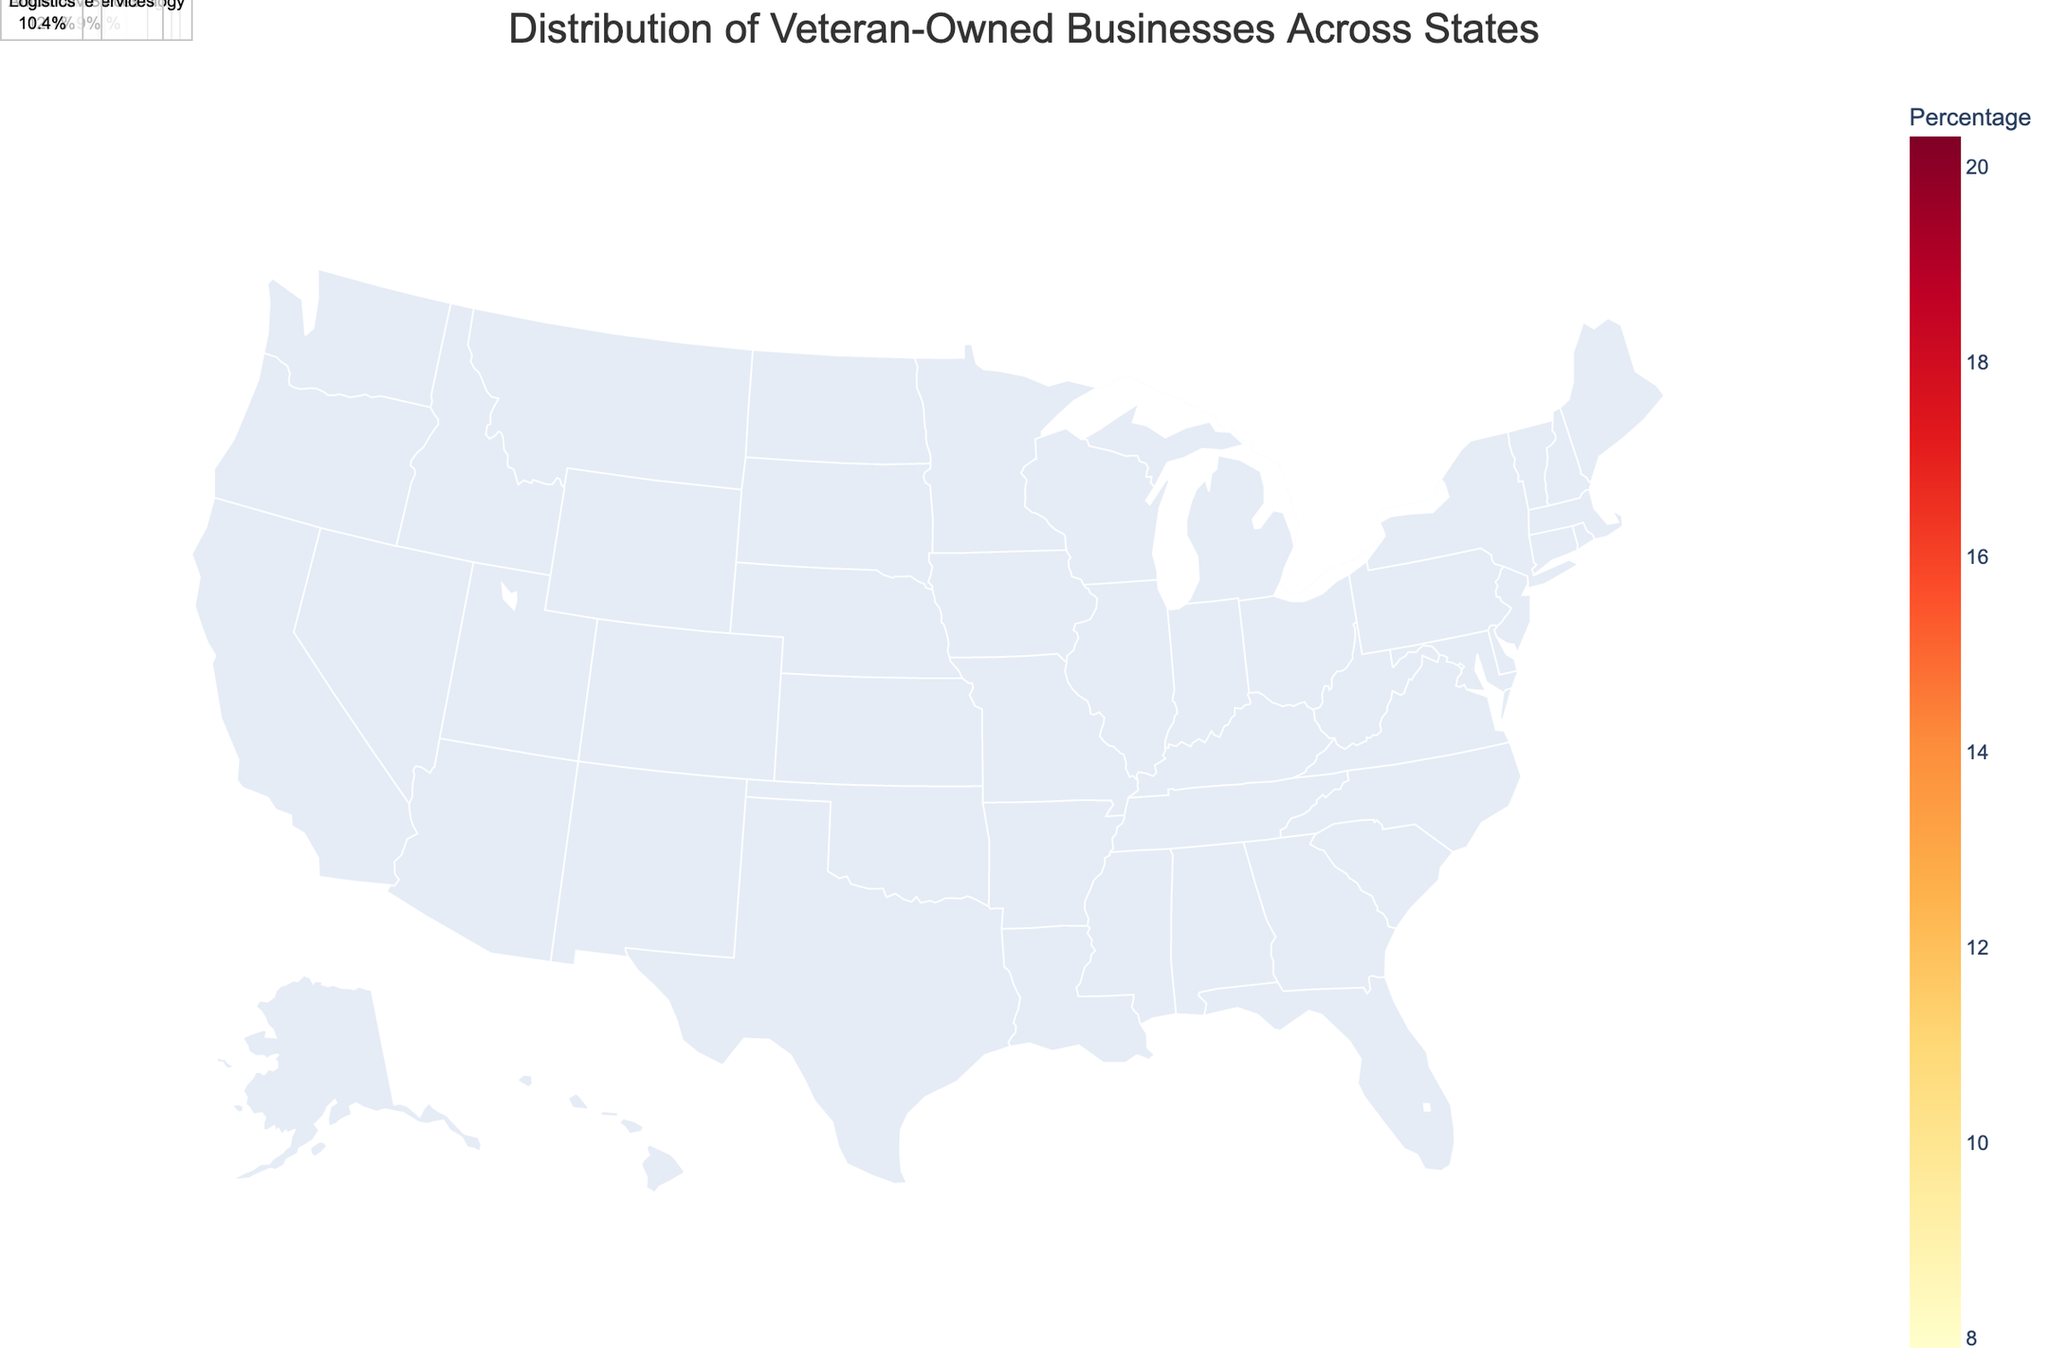What's the title of the figure? The title is displayed at the top of the figure, indicating the main topic it covers. It helps the viewer to understand the overall content at a glance.
Answer: Distribution of Veteran-Owned Businesses Across States Which state has the highest percentage of veteran-owned businesses in defense contracting? By looking at the color coding and hover information, you locate the state labeled with the highest percentage in the defense contracting industry.
Answer: Virginia What industry has a 17.5% share of veteran-owned businesses in Arizona? The chart annotates the state along with associated industry and percentage figures. Locate Arizona and read off the corresponding industry.
Answer: Security Services Compare the percentage of veteran-owned businesses involved in manufacturing in Ohio and the percentage in aerospace in Colorado. Which is higher? Locate Ohio and Colorado on the map, check their associated percentages for manufacturing and aerospace respectively, and compare the two figures.
Answer: Aerospace in Colorado What's the average percentage of veteran-owned businesses in healthcare, logistics, and agriculture in North Carolina, Alabama, and Illinois respectively? Calculate the average of the percentages: (10.6 (Healthcare in NC) + 10.4 (Logistics in AL) + 8.3 (Agriculture in IL))/3.
Answer: 9.77 Which state has the lowest percentage of veteran-owned businesses and what industry is it in? Identify the state with the lightest color (lowest percentage) and read the associated industry from the annotation or hover information.
Answer: Pennsylvania, Education Services How many states have a percentage of veteran-owned businesses greater than 15%? Count the number of states from the color coding and annotations where the percentage exceeds 15%.
Answer: 5 What industry has a 12.8% share of veteran-owned businesses in Florida? Hover over the state of Florida on the map or read its annotation to determine the industry associated with 12.8%.
Answer: Retail Trade Compare the percentage of veteran-owned businesses in construction in Texas with that in professional services in California. Which state has a higher percentage? Locate Texas and California on the map, check the percentages for construction and professional services respectively, and compare them.
Answer: Texas What is the sum of the percentages of veteran-owned businesses in construction in Texas and aerospace in Colorado? Add the percentages of veteran-owned businesses in construction in Texas (18.5) and aerospace in Colorado (16.1).
Answer: 34.6 